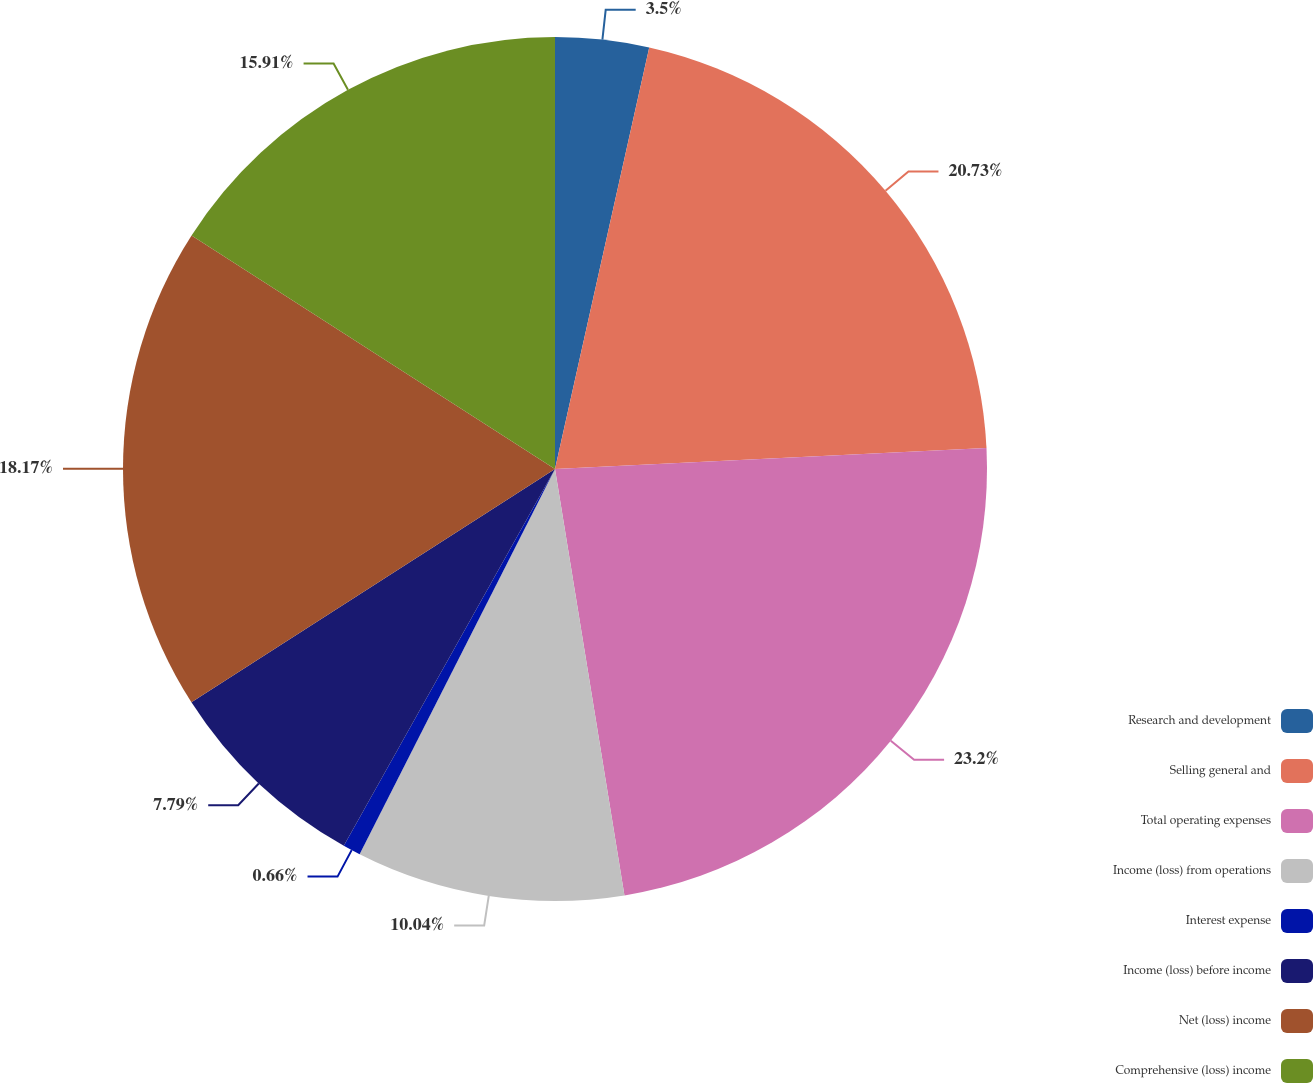Convert chart. <chart><loc_0><loc_0><loc_500><loc_500><pie_chart><fcel>Research and development<fcel>Selling general and<fcel>Total operating expenses<fcel>Income (loss) from operations<fcel>Interest expense<fcel>Income (loss) before income<fcel>Net (loss) income<fcel>Comprehensive (loss) income<nl><fcel>3.5%<fcel>20.73%<fcel>23.2%<fcel>10.04%<fcel>0.66%<fcel>7.79%<fcel>18.17%<fcel>15.91%<nl></chart> 